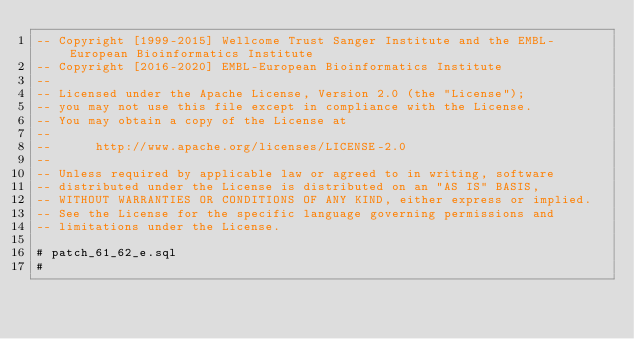Convert code to text. <code><loc_0><loc_0><loc_500><loc_500><_SQL_>-- Copyright [1999-2015] Wellcome Trust Sanger Institute and the EMBL-European Bioinformatics Institute
-- Copyright [2016-2020] EMBL-European Bioinformatics Institute
-- 
-- Licensed under the Apache License, Version 2.0 (the "License");
-- you may not use this file except in compliance with the License.
-- You may obtain a copy of the License at
-- 
--      http://www.apache.org/licenses/LICENSE-2.0
-- 
-- Unless required by applicable law or agreed to in writing, software
-- distributed under the License is distributed on an "AS IS" BASIS,
-- WITHOUT WARRANTIES OR CONDITIONS OF ANY KIND, either express or implied.
-- See the License for the specific language governing permissions and
-- limitations under the License.

# patch_61_62_e.sql
#</code> 